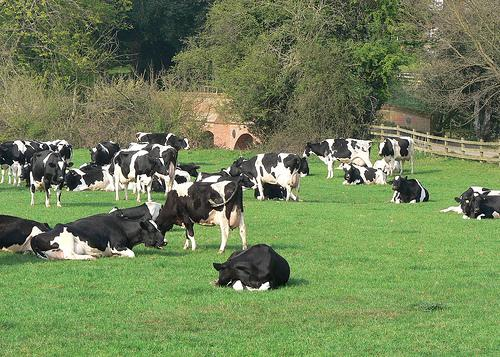List the main items in the image and their corresponding activities. Cow: sleeping, tail: swinging, field: grassy, fence: wooden and surrounding, bridge: brick in the background. Write a brief description of the activities of the key subject in the image. Black and white cow at leisure, reclined in grass, tail gently swaying. Identify the main object in the image and use a unique writing style to describe it. Encounter we do, amidst the verdant meadows, a sleeping cow of monochrome hue, adorned in spots of white and black. Briefly describe the setting of the image. Cows occupy a grassy field featuring a wooden fence, brick bridge, and surrounded by trees. Mention the primary animal in the image and describe its appearance and activity. The cow with black and white spots is lying down and sleeping on the grass in the field, with its tail relaxed and slightly swinging. In a concise way, explain the main subject and its environment in the image. Sleeping cow, black and white, resting on lush field, near wooden fence and trees. Write a short haiku about the main subject of the image. In still field, cow rests. Using descriptive language, explain what the central subject of the image is doing. Enveloped by the lush grassy fields, the magnificent black and white cow languidly slumbers under the radiant sun. Mention the primary focus of the image and what it is engaged in. A black and white cow is lying down in the grassy field, taking a restful sleep. Point out the main elements of the landscape in the image. There is a grassy field with cows, trees along the field, a path beside the grass, a wooden fence, and a brick bridge in the background. 